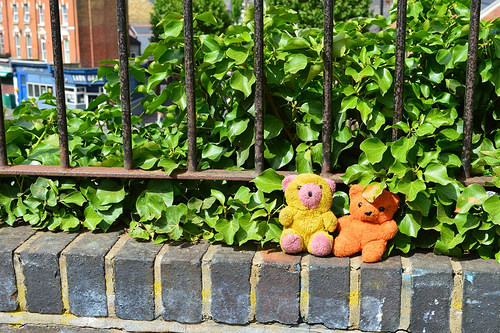<image>
Can you confirm if the bear is behind the fence? No. The bear is not behind the fence. From this viewpoint, the bear appears to be positioned elsewhere in the scene. 